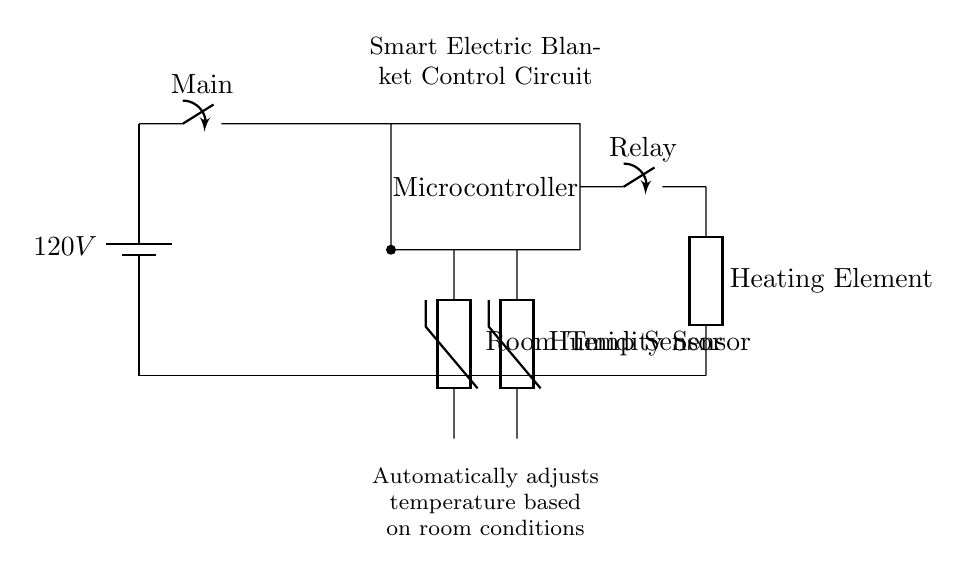What type of sensors are used in this circuit? The circuit utilizes two types of thermistors: one for measuring room temperature and another for humidity. This can be identified by the labels on the components in the diagram.
Answer: Thermistors What component controls the electric blanket's heating element? The relay component directly connects to the heating element, indicating that it is responsible for controlling the power to the blanket based on the microcontroller’s input.
Answer: Relay What is the input voltage of this circuit? The diagram specifies a battery labeled as 120V at the power source, indicating the voltage supplied to the circuit.
Answer: 120V How does the microcontroller interact with the sensors? The microcontroller receives inputs from both the room temperature sensor and the humidity sensor, allowing it to determine the optimal heating conditions for the blanket based on the data received.
Answer: Receives inputs What is the function of the main switch in this circuit? The main switch allows the user to control the overall power supply to the circuit, either enabling or disconnecting the entire system as needed.
Answer: Power control What is the purpose of this smart electric blanket circuit? The circuit is designed to automatically adjust the temperature of the electric blanket based on the environment, specifically room conditions detected by the sensors.
Answer: Automatic temperature adjustment 